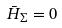Convert formula to latex. <formula><loc_0><loc_0><loc_500><loc_500>\bar { H } _ { \Sigma } = 0</formula> 